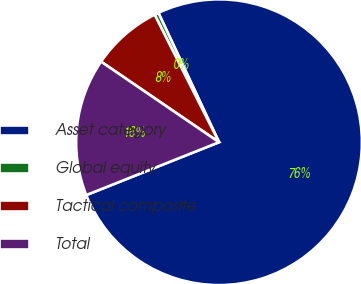<chart> <loc_0><loc_0><loc_500><loc_500><pie_chart><fcel>Asset category<fcel>Global equity<fcel>Tactical composite<fcel>Total<nl><fcel>75.94%<fcel>0.47%<fcel>8.02%<fcel>15.57%<nl></chart> 